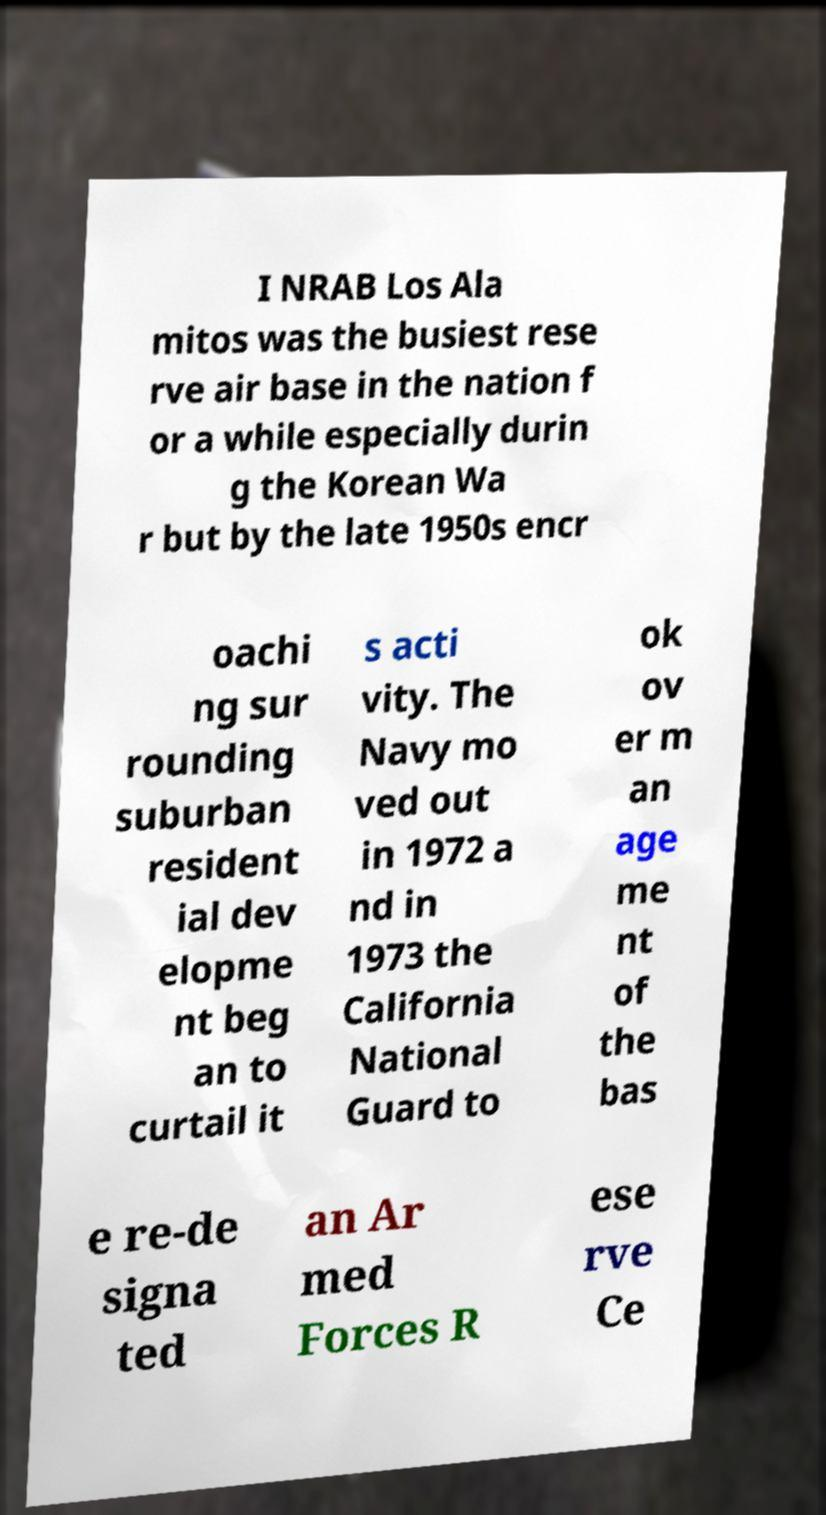Can you read and provide the text displayed in the image?This photo seems to have some interesting text. Can you extract and type it out for me? I NRAB Los Ala mitos was the busiest rese rve air base in the nation f or a while especially durin g the Korean Wa r but by the late 1950s encr oachi ng sur rounding suburban resident ial dev elopme nt beg an to curtail it s acti vity. The Navy mo ved out in 1972 a nd in 1973 the California National Guard to ok ov er m an age me nt of the bas e re-de signa ted an Ar med Forces R ese rve Ce 